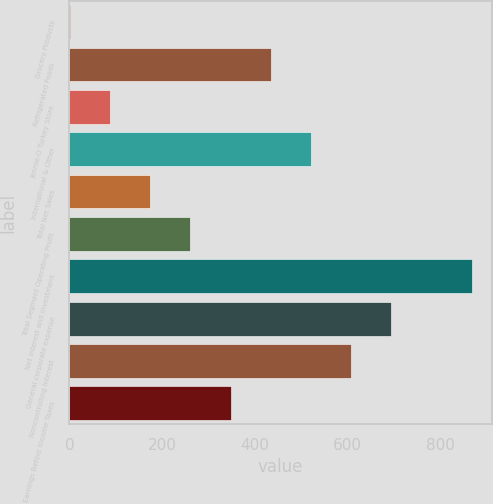Convert chart. <chart><loc_0><loc_0><loc_500><loc_500><bar_chart><fcel>Grocery Products<fcel>Refrigerated Foods<fcel>Jennie-O Turkey Store<fcel>International & Other<fcel>Total Net Sales<fcel>Total Segment Operating Profit<fcel>Net interest and investment<fcel>General corporate expense<fcel>Noncontrolling interest<fcel>Earnings Before Income Taxes<nl><fcel>1.3<fcel>434.1<fcel>87.86<fcel>520.66<fcel>174.42<fcel>260.98<fcel>866.9<fcel>693.78<fcel>607.22<fcel>347.54<nl></chart> 